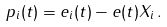<formula> <loc_0><loc_0><loc_500><loc_500>p _ { i } ( t ) = e _ { i } ( t ) - e ( t ) X _ { i } \, .</formula> 